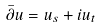<formula> <loc_0><loc_0><loc_500><loc_500>\bar { \partial } u = u _ { s } + i u _ { t }</formula> 